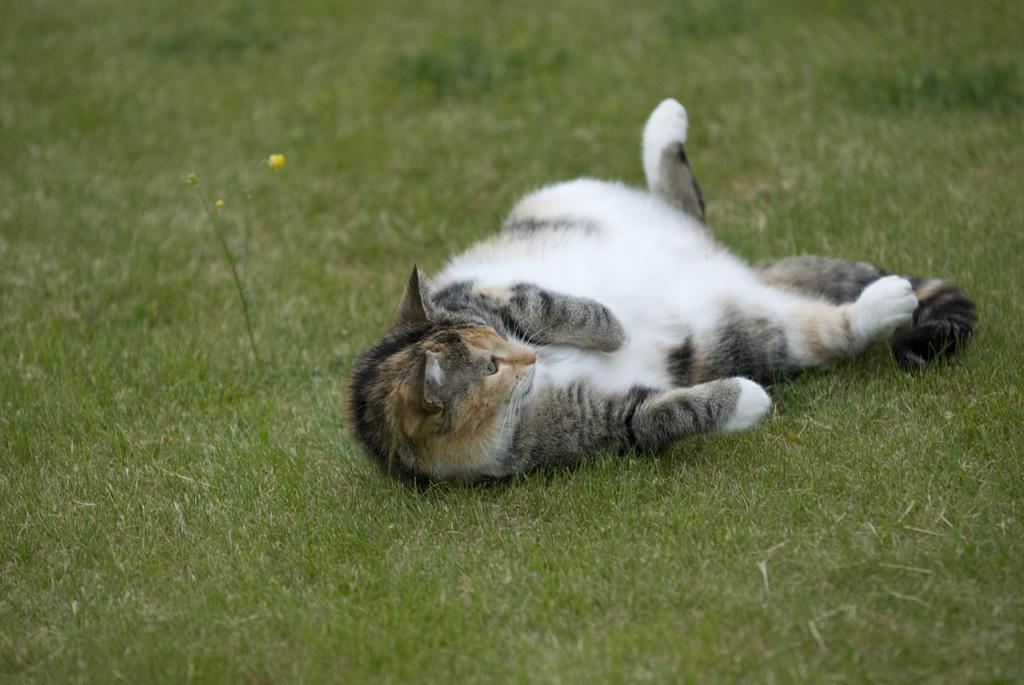What type of animal is in the image? There is a cat in the image. Can you describe the appearance of the cat? The cat has black, white, and brown colors. Where is the cat located in the image? The cat is on the grass. What can be seen on the plant in the image? There is a yellow-colored bud on a plant in the image. What type of verse is being recited by the cat in the image? There is no indication in the image that the cat is reciting any verse, as cats do not have the ability to speak or recite poetry. 